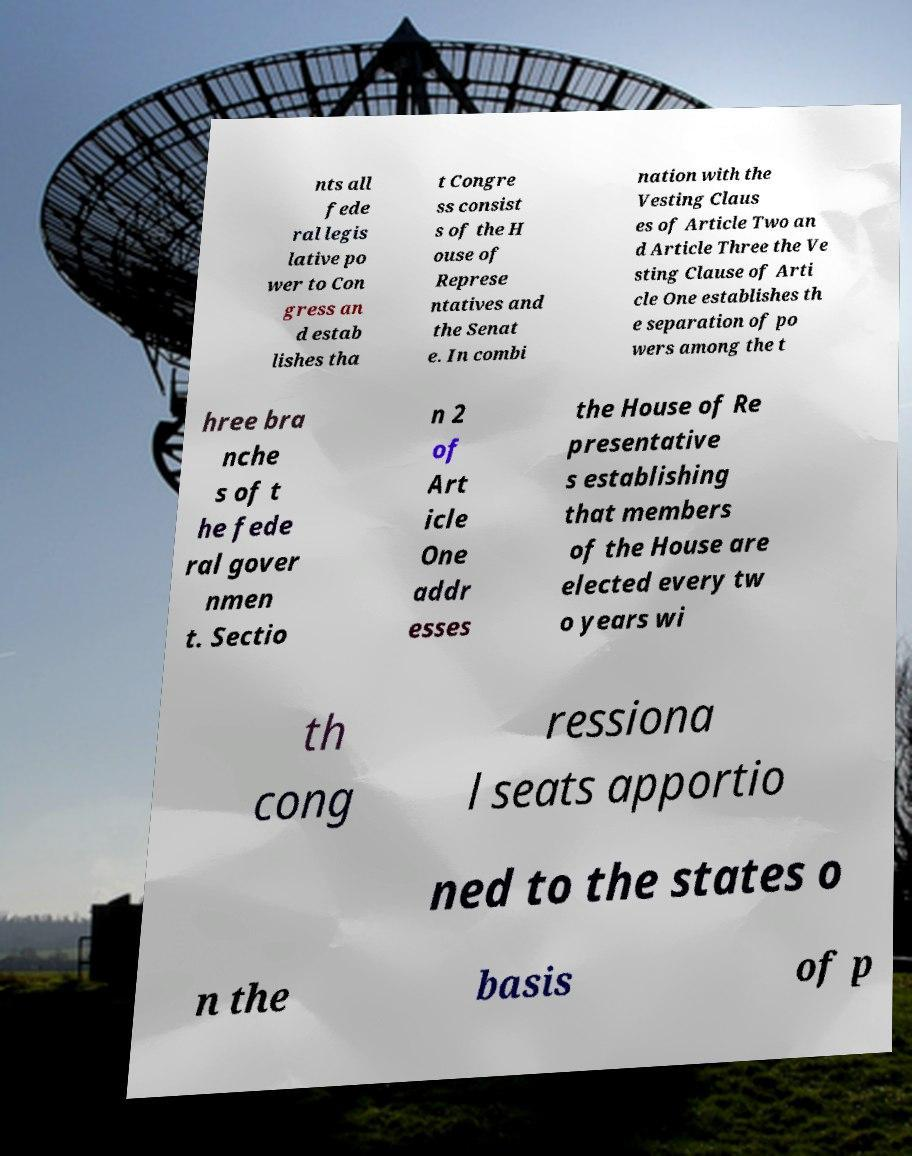There's text embedded in this image that I need extracted. Can you transcribe it verbatim? nts all fede ral legis lative po wer to Con gress an d estab lishes tha t Congre ss consist s of the H ouse of Represe ntatives and the Senat e. In combi nation with the Vesting Claus es of Article Two an d Article Three the Ve sting Clause of Arti cle One establishes th e separation of po wers among the t hree bra nche s of t he fede ral gover nmen t. Sectio n 2 of Art icle One addr esses the House of Re presentative s establishing that members of the House are elected every tw o years wi th cong ressiona l seats apportio ned to the states o n the basis of p 